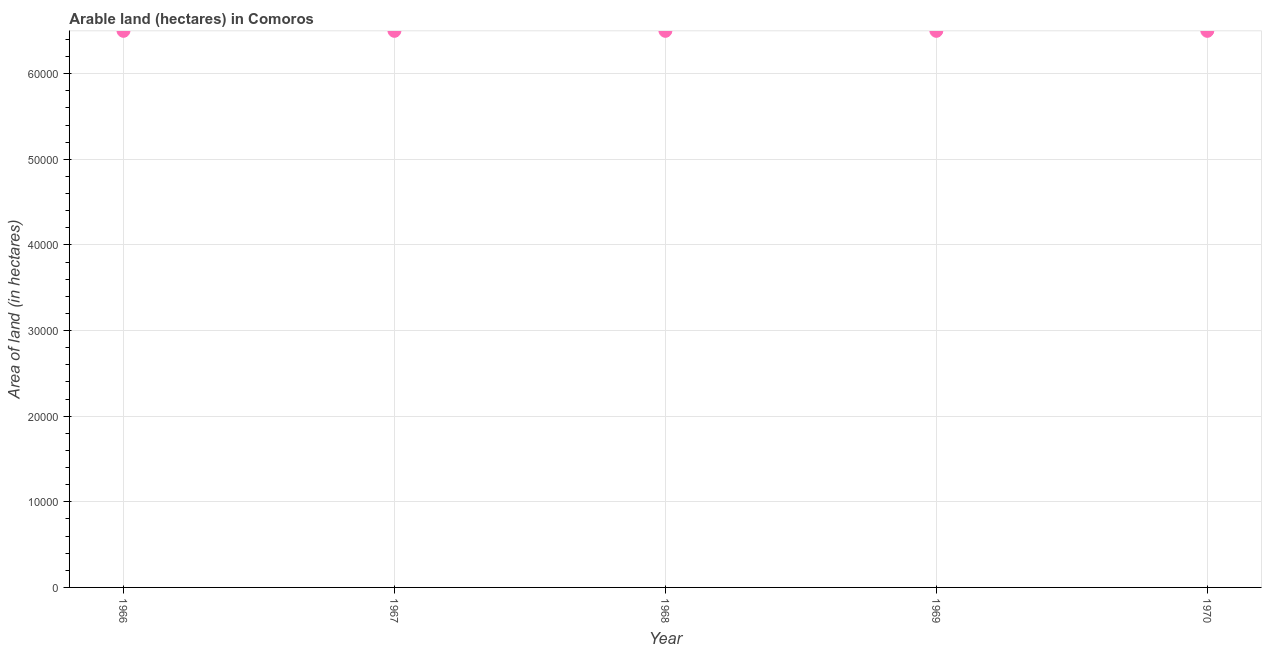What is the area of land in 1970?
Provide a short and direct response. 6.50e+04. Across all years, what is the maximum area of land?
Offer a terse response. 6.50e+04. Across all years, what is the minimum area of land?
Offer a terse response. 6.50e+04. In which year was the area of land maximum?
Offer a very short reply. 1966. In which year was the area of land minimum?
Provide a short and direct response. 1966. What is the sum of the area of land?
Your answer should be compact. 3.25e+05. What is the average area of land per year?
Offer a terse response. 6.50e+04. What is the median area of land?
Your response must be concise. 6.50e+04. What is the ratio of the area of land in 1969 to that in 1970?
Offer a very short reply. 1. Is the area of land in 1968 less than that in 1970?
Give a very brief answer. No. Is the difference between the area of land in 1968 and 1969 greater than the difference between any two years?
Your answer should be very brief. Yes. What is the difference between the highest and the second highest area of land?
Give a very brief answer. 0. Is the sum of the area of land in 1966 and 1967 greater than the maximum area of land across all years?
Offer a terse response. Yes. What is the difference between the highest and the lowest area of land?
Ensure brevity in your answer.  0. How many dotlines are there?
Provide a short and direct response. 1. Are the values on the major ticks of Y-axis written in scientific E-notation?
Give a very brief answer. No. Does the graph contain any zero values?
Keep it short and to the point. No. Does the graph contain grids?
Offer a very short reply. Yes. What is the title of the graph?
Make the answer very short. Arable land (hectares) in Comoros. What is the label or title of the X-axis?
Your answer should be compact. Year. What is the label or title of the Y-axis?
Your answer should be very brief. Area of land (in hectares). What is the Area of land (in hectares) in 1966?
Offer a terse response. 6.50e+04. What is the Area of land (in hectares) in 1967?
Ensure brevity in your answer.  6.50e+04. What is the Area of land (in hectares) in 1968?
Your response must be concise. 6.50e+04. What is the Area of land (in hectares) in 1969?
Offer a very short reply. 6.50e+04. What is the Area of land (in hectares) in 1970?
Give a very brief answer. 6.50e+04. What is the difference between the Area of land (in hectares) in 1966 and 1969?
Ensure brevity in your answer.  0. What is the difference between the Area of land (in hectares) in 1966 and 1970?
Keep it short and to the point. 0. What is the difference between the Area of land (in hectares) in 1967 and 1969?
Give a very brief answer. 0. What is the difference between the Area of land (in hectares) in 1967 and 1970?
Your response must be concise. 0. What is the ratio of the Area of land (in hectares) in 1966 to that in 1968?
Ensure brevity in your answer.  1. What is the ratio of the Area of land (in hectares) in 1966 to that in 1970?
Your answer should be compact. 1. What is the ratio of the Area of land (in hectares) in 1967 to that in 1970?
Offer a terse response. 1. What is the ratio of the Area of land (in hectares) in 1968 to that in 1969?
Give a very brief answer. 1. What is the ratio of the Area of land (in hectares) in 1968 to that in 1970?
Ensure brevity in your answer.  1. What is the ratio of the Area of land (in hectares) in 1969 to that in 1970?
Provide a short and direct response. 1. 